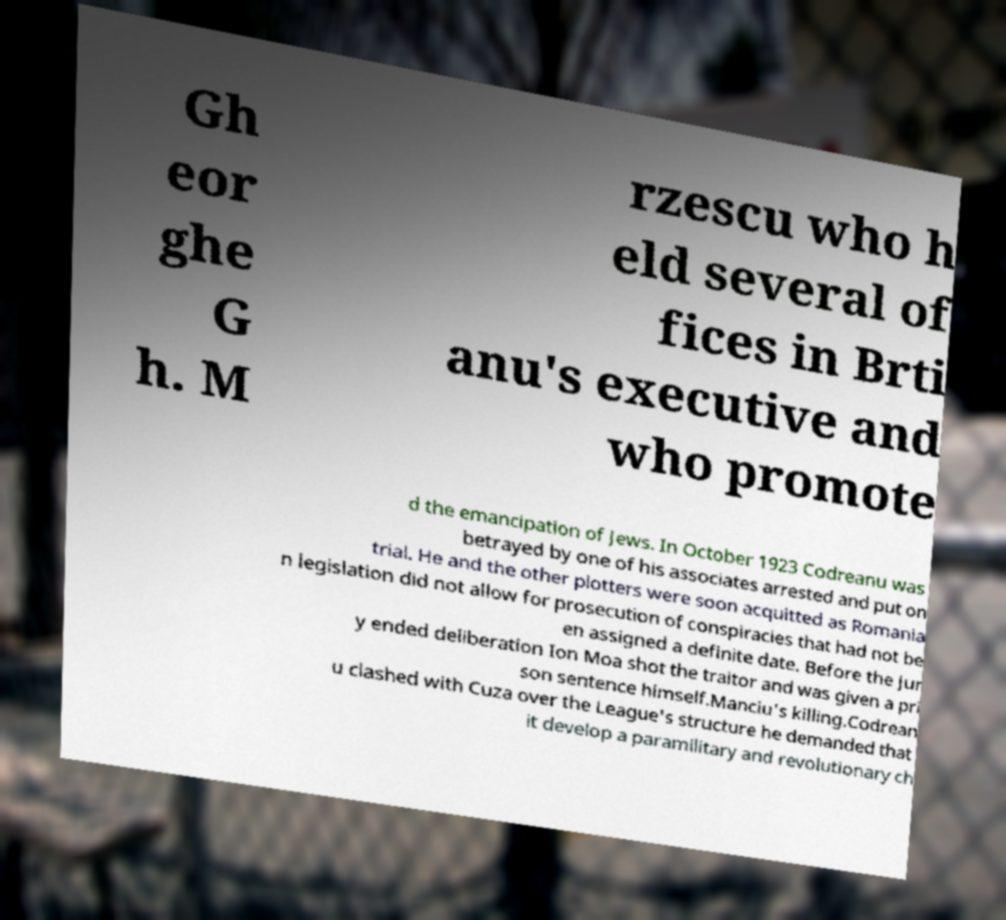Can you read and provide the text displayed in the image?This photo seems to have some interesting text. Can you extract and type it out for me? Gh eor ghe G h. M rzescu who h eld several of fices in Brti anu's executive and who promote d the emancipation of Jews. In October 1923 Codreanu was betrayed by one of his associates arrested and put on trial. He and the other plotters were soon acquitted as Romania n legislation did not allow for prosecution of conspiracies that had not be en assigned a definite date. Before the jur y ended deliberation Ion Moa shot the traitor and was given a pri son sentence himself.Manciu's killing.Codrean u clashed with Cuza over the League's structure he demanded that it develop a paramilitary and revolutionary ch 